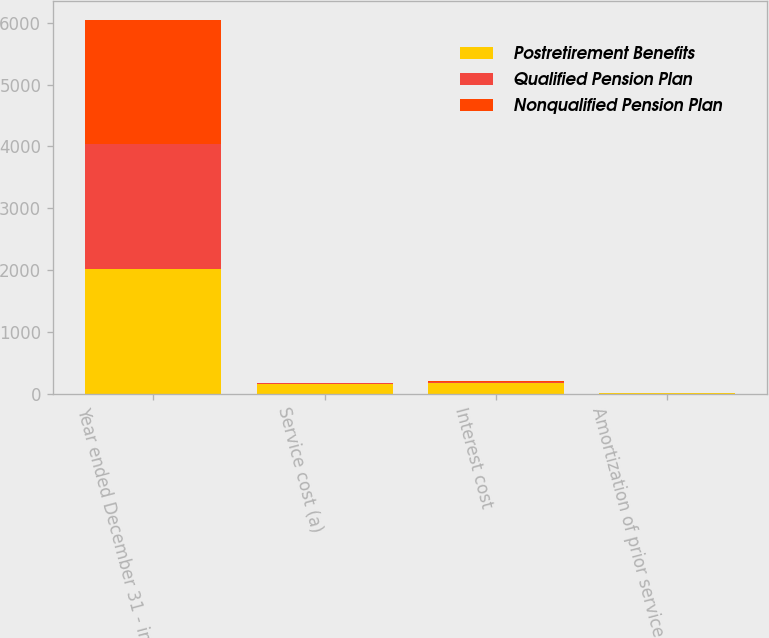Convert chart to OTSL. <chart><loc_0><loc_0><loc_500><loc_500><stacked_bar_chart><ecel><fcel>Year ended December 31 - in<fcel>Service cost (a)<fcel>Interest cost<fcel>Amortization of prior service<nl><fcel>Postretirement Benefits<fcel>2017<fcel>160<fcel>179<fcel>3<nl><fcel>Qualified Pension Plan<fcel>2017<fcel>3<fcel>10<fcel>7<nl><fcel>Nonqualified Pension Plan<fcel>2017<fcel>5<fcel>14<fcel>1<nl></chart> 